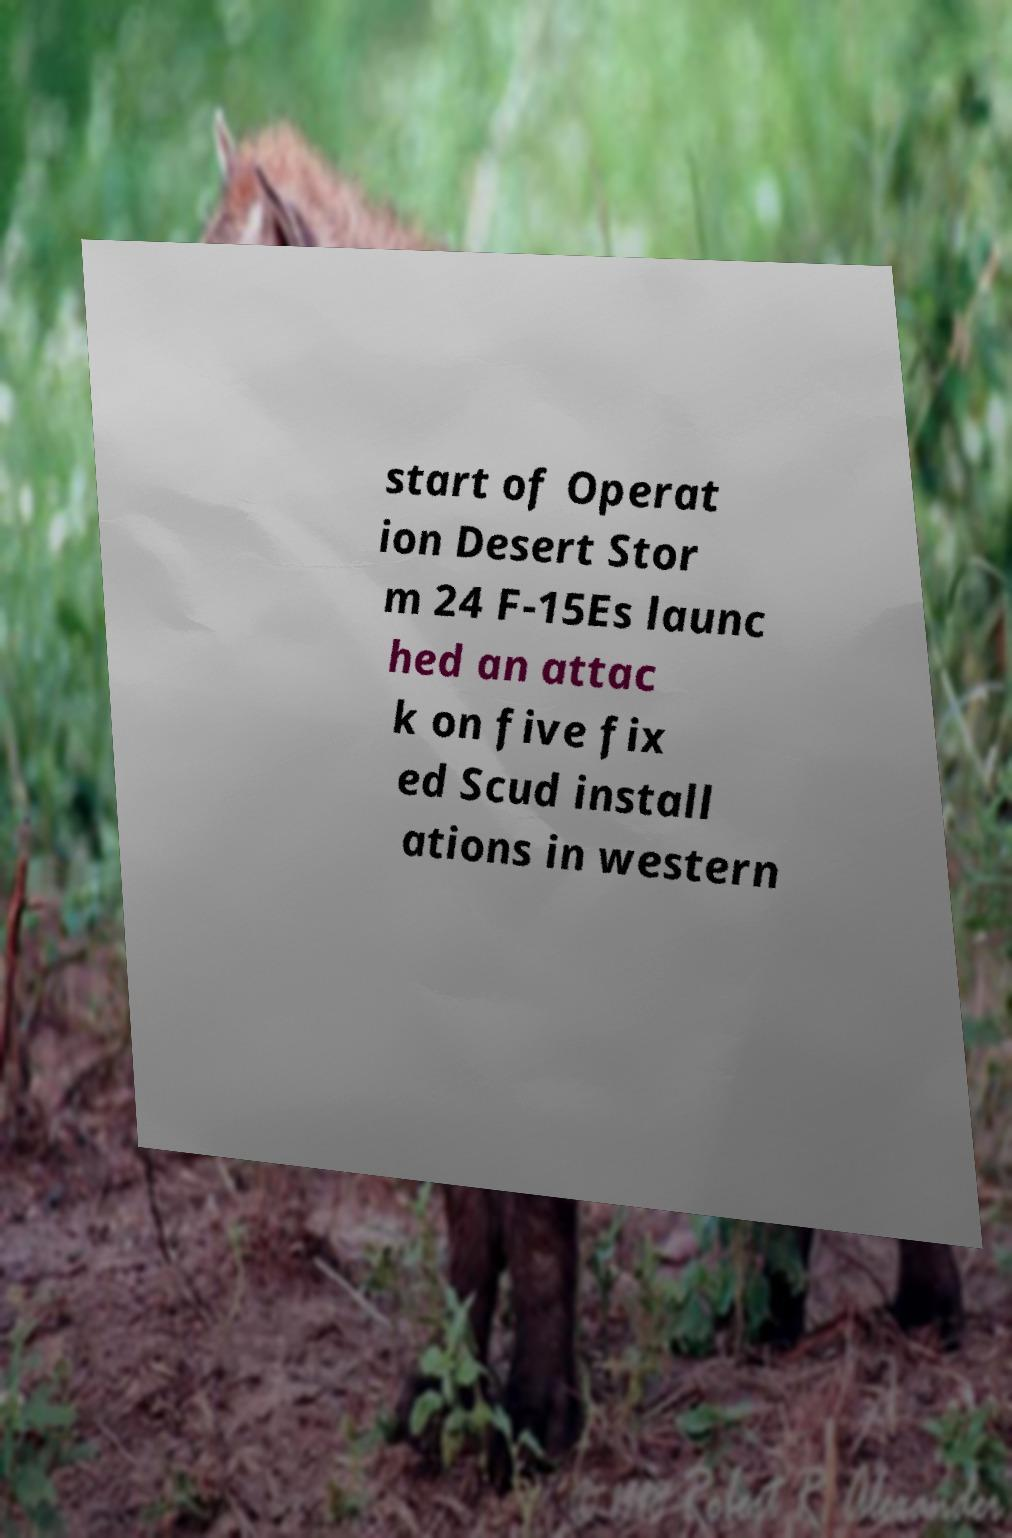Please read and relay the text visible in this image. What does it say? start of Operat ion Desert Stor m 24 F-15Es launc hed an attac k on five fix ed Scud install ations in western 